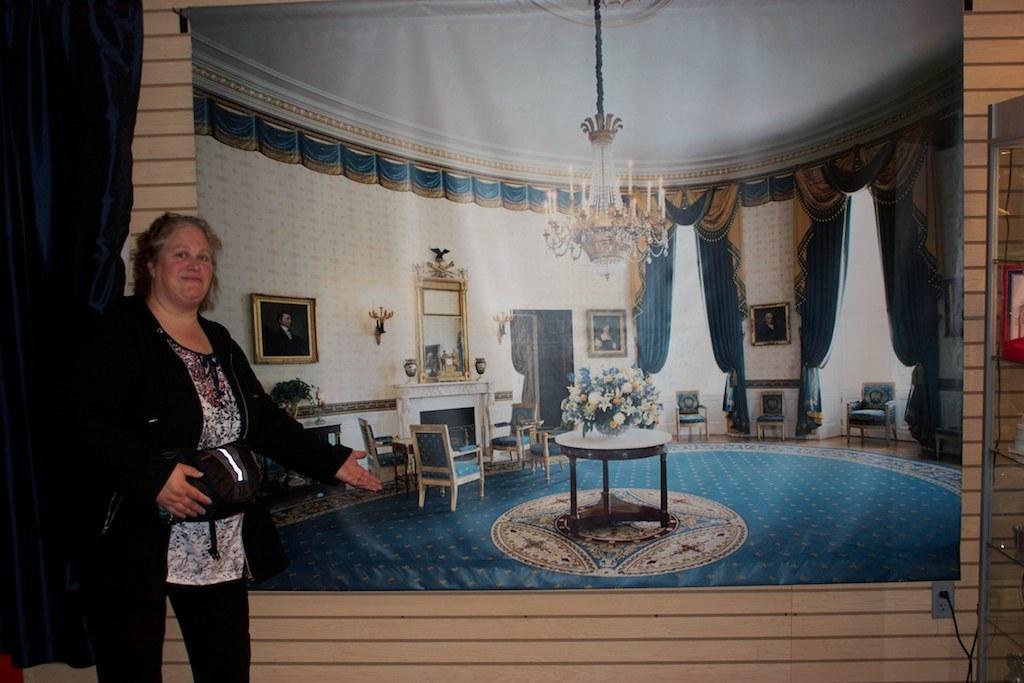Please provide a concise description of this image. In this image on the left side there is one woman who is standing and she is holding a bag and on the top there is a ceiling and wall is there and on the wall there is one poster in that poster there are chairs, table, flower pot, chandelier and curtains and windows are there. 